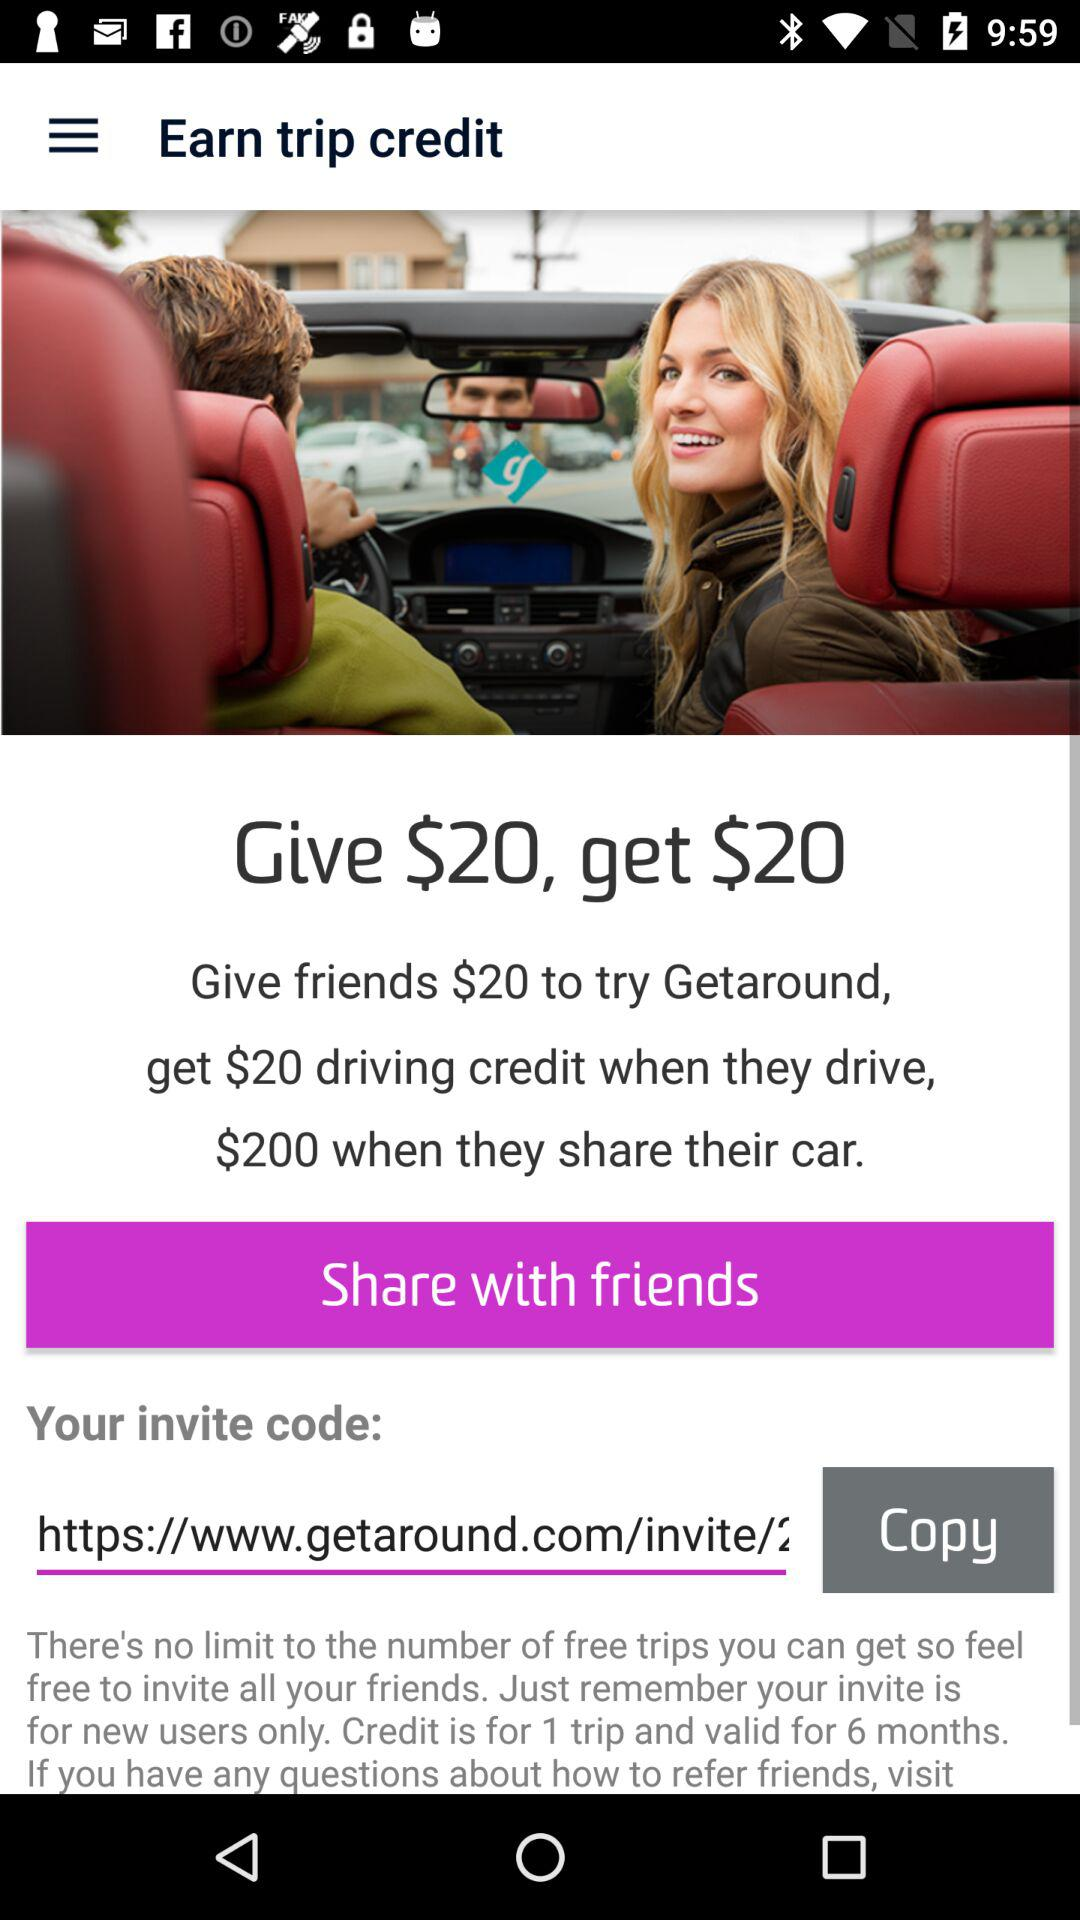How much is to be given to get $20? You have to give $20. 